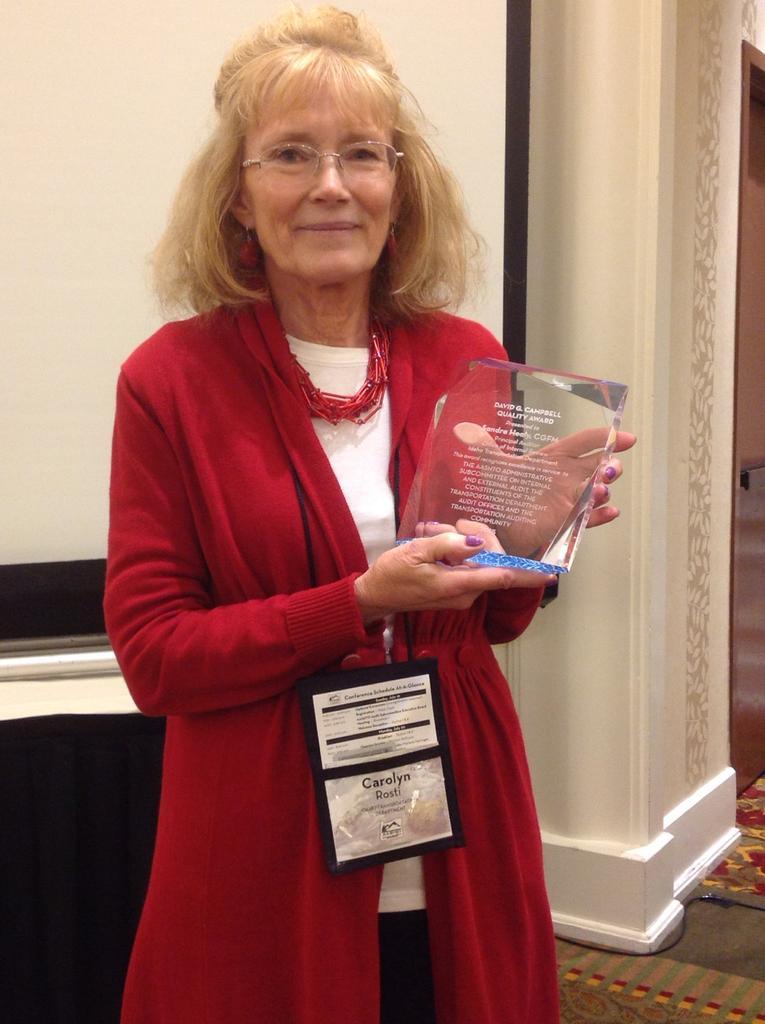Please provide a concise description of this image. In this image there is an old woman in the middle who is standing on the floor by holding a memento. In the background there is a screen. The woman is wearing an id card and a red coat. 